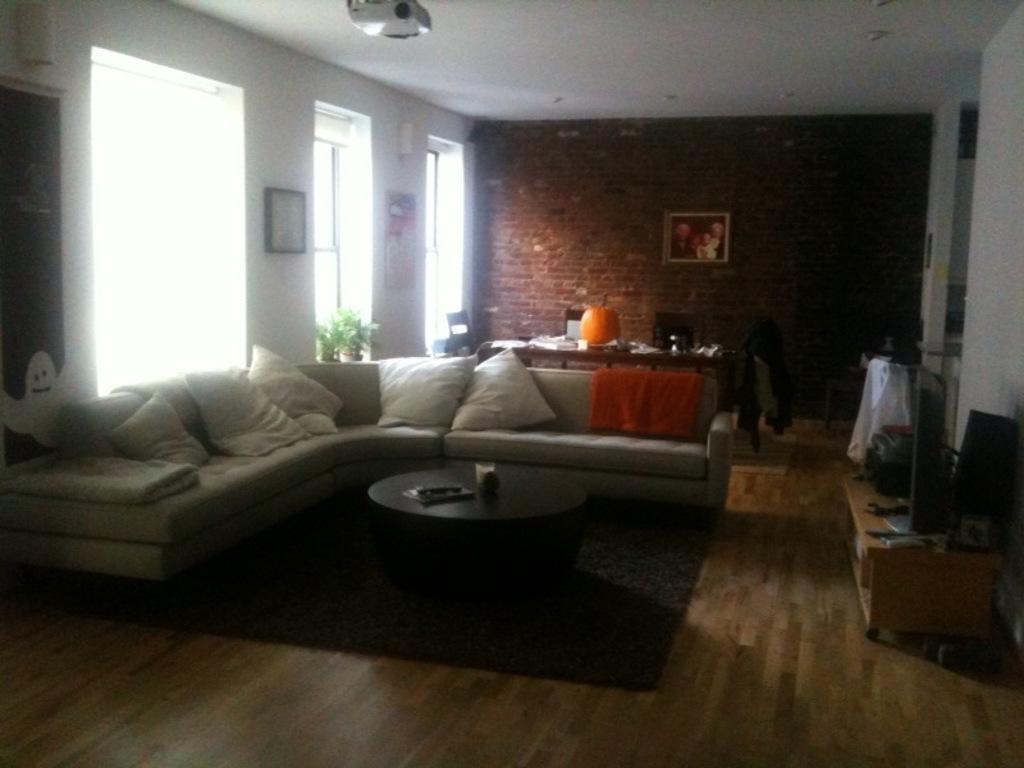Describe this image in one or two sentences. In the middle there is a sofa on that there are many pillows ,in front of the sofa there is a table. I think this is a house. In the back ground there is a wall ,photo frame ,table ,chair and window. At the top there is a projector. 